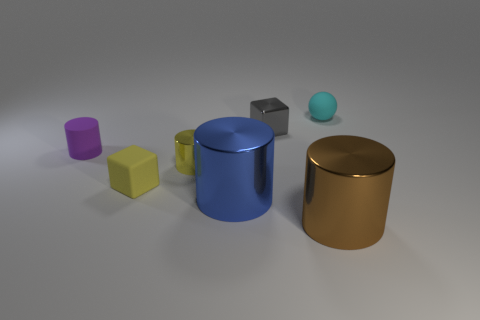Subtract all tiny yellow cylinders. How many cylinders are left? 3 Subtract all purple cylinders. How many cylinders are left? 3 Subtract 1 cylinders. How many cylinders are left? 3 Add 1 tiny rubber cylinders. How many objects exist? 8 Subtract all cyan cylinders. Subtract all purple balls. How many cylinders are left? 4 Subtract all blocks. How many objects are left? 5 Subtract all tiny gray objects. Subtract all gray shiny blocks. How many objects are left? 5 Add 7 small rubber cubes. How many small rubber cubes are left? 8 Add 3 small cylinders. How many small cylinders exist? 5 Subtract 0 purple balls. How many objects are left? 7 